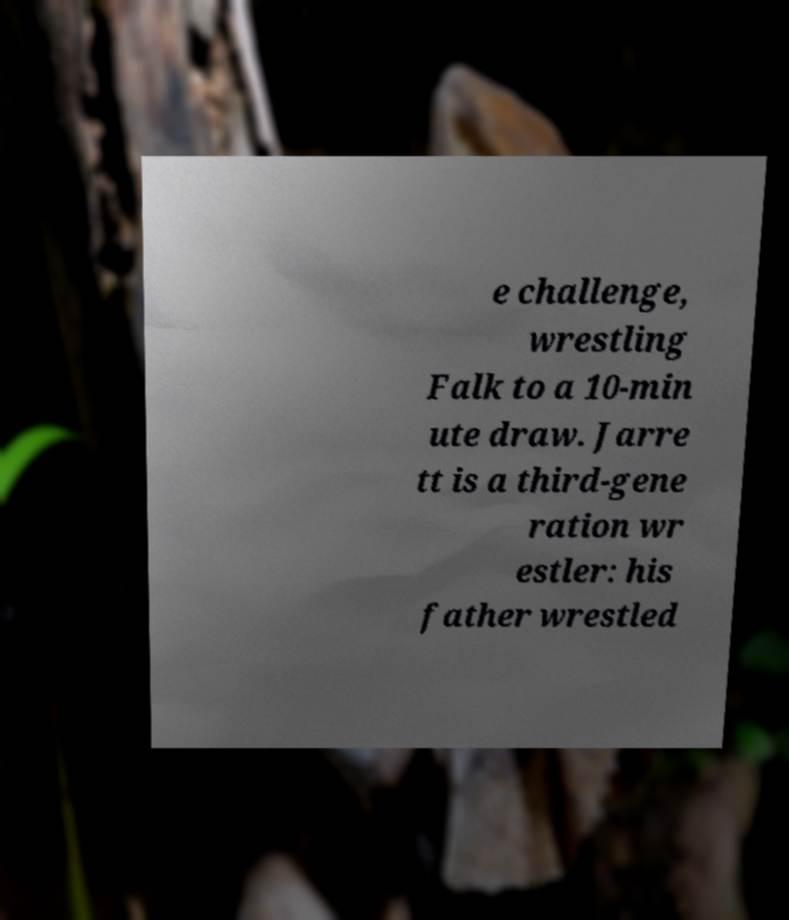I need the written content from this picture converted into text. Can you do that? e challenge, wrestling Falk to a 10-min ute draw. Jarre tt is a third-gene ration wr estler: his father wrestled 